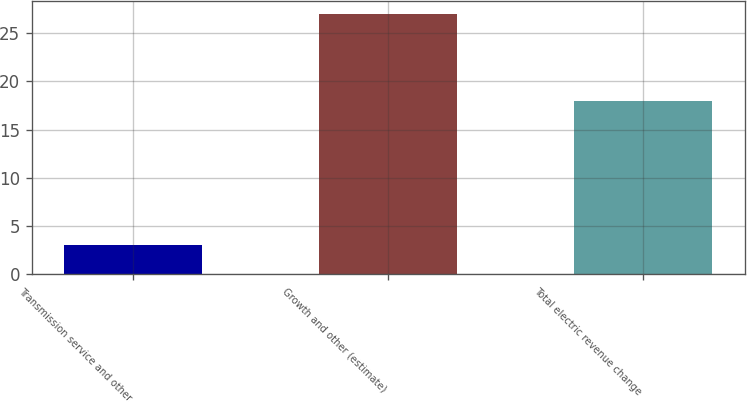Convert chart to OTSL. <chart><loc_0><loc_0><loc_500><loc_500><bar_chart><fcel>Transmission service and other<fcel>Growth and other (estimate)<fcel>Total electric revenue change<nl><fcel>3<fcel>27<fcel>18<nl></chart> 